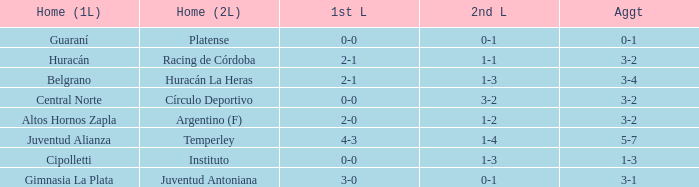In the second leg, who had a home game with a 0-1 score and experienced a 0-0 tie during the first leg? Platense. 